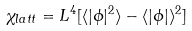Convert formula to latex. <formula><loc_0><loc_0><loc_500><loc_500>\chi _ { l a t t } = L ^ { 4 } [ \langle | \phi | ^ { 2 } \rangle - \langle | \phi | \rangle ^ { 2 } ]</formula> 